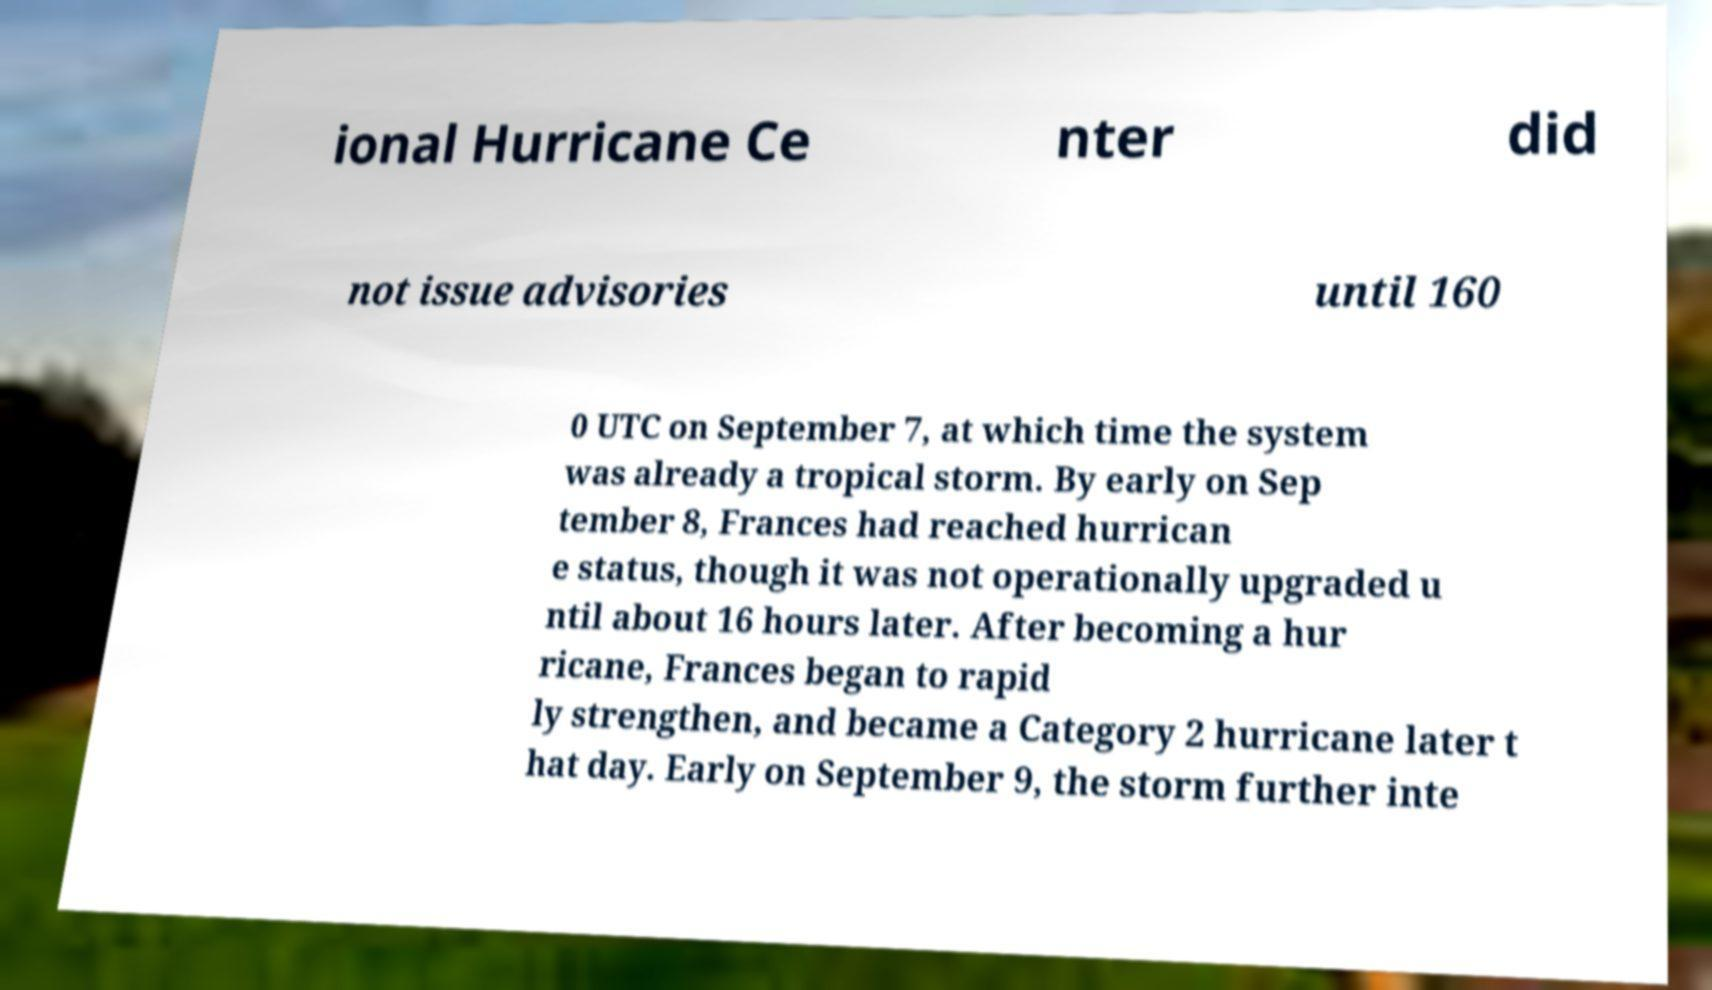Can you accurately transcribe the text from the provided image for me? ional Hurricane Ce nter did not issue advisories until 160 0 UTC on September 7, at which time the system was already a tropical storm. By early on Sep tember 8, Frances had reached hurrican e status, though it was not operationally upgraded u ntil about 16 hours later. After becoming a hur ricane, Frances began to rapid ly strengthen, and became a Category 2 hurricane later t hat day. Early on September 9, the storm further inte 